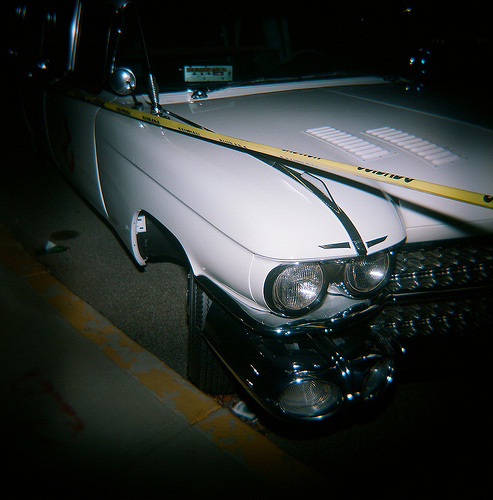<image>
Is there a caution tape on the road? No. The caution tape is not positioned on the road. They may be near each other, but the caution tape is not supported by or resting on top of the road. 